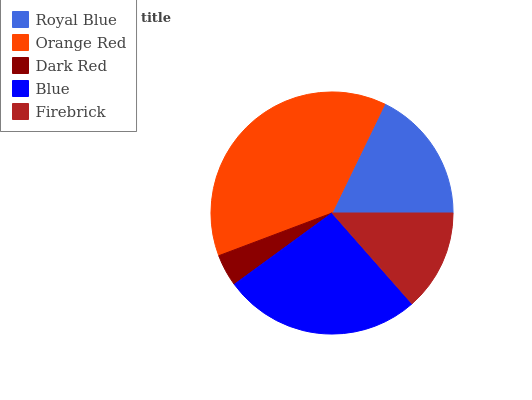Is Dark Red the minimum?
Answer yes or no. Yes. Is Orange Red the maximum?
Answer yes or no. Yes. Is Orange Red the minimum?
Answer yes or no. No. Is Dark Red the maximum?
Answer yes or no. No. Is Orange Red greater than Dark Red?
Answer yes or no. Yes. Is Dark Red less than Orange Red?
Answer yes or no. Yes. Is Dark Red greater than Orange Red?
Answer yes or no. No. Is Orange Red less than Dark Red?
Answer yes or no. No. Is Royal Blue the high median?
Answer yes or no. Yes. Is Royal Blue the low median?
Answer yes or no. Yes. Is Blue the high median?
Answer yes or no. No. Is Firebrick the low median?
Answer yes or no. No. 